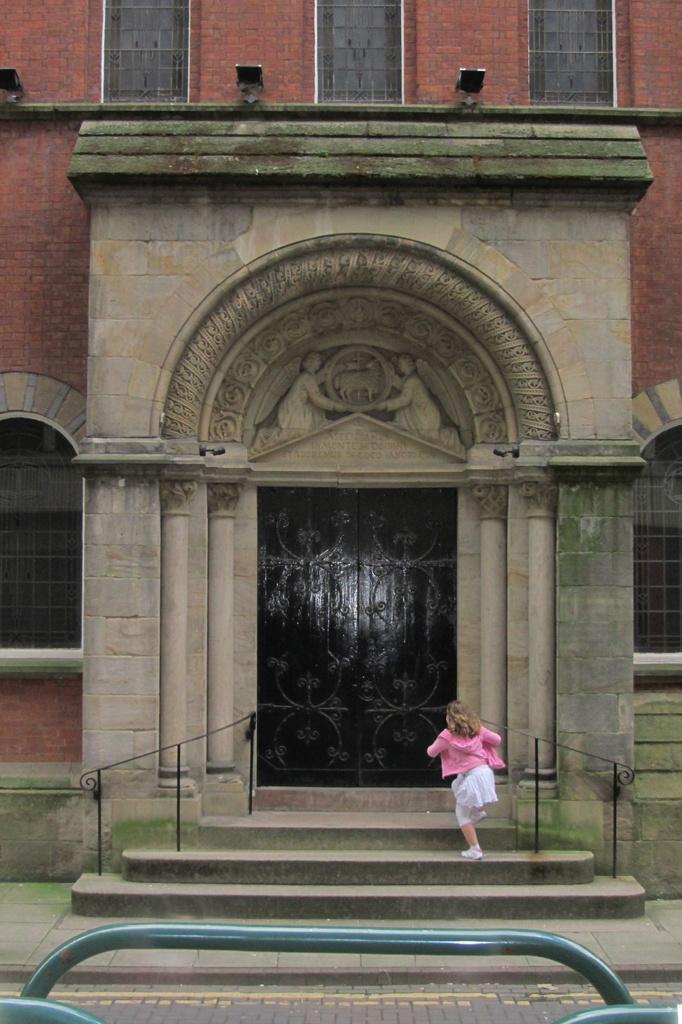Please provide a concise description of this image. In this image we can see a girl standing on a staircase with metal railing. In the center of the image we can see a building with windows, pillars and a door. In the background, we can see some lights and metal poles. 